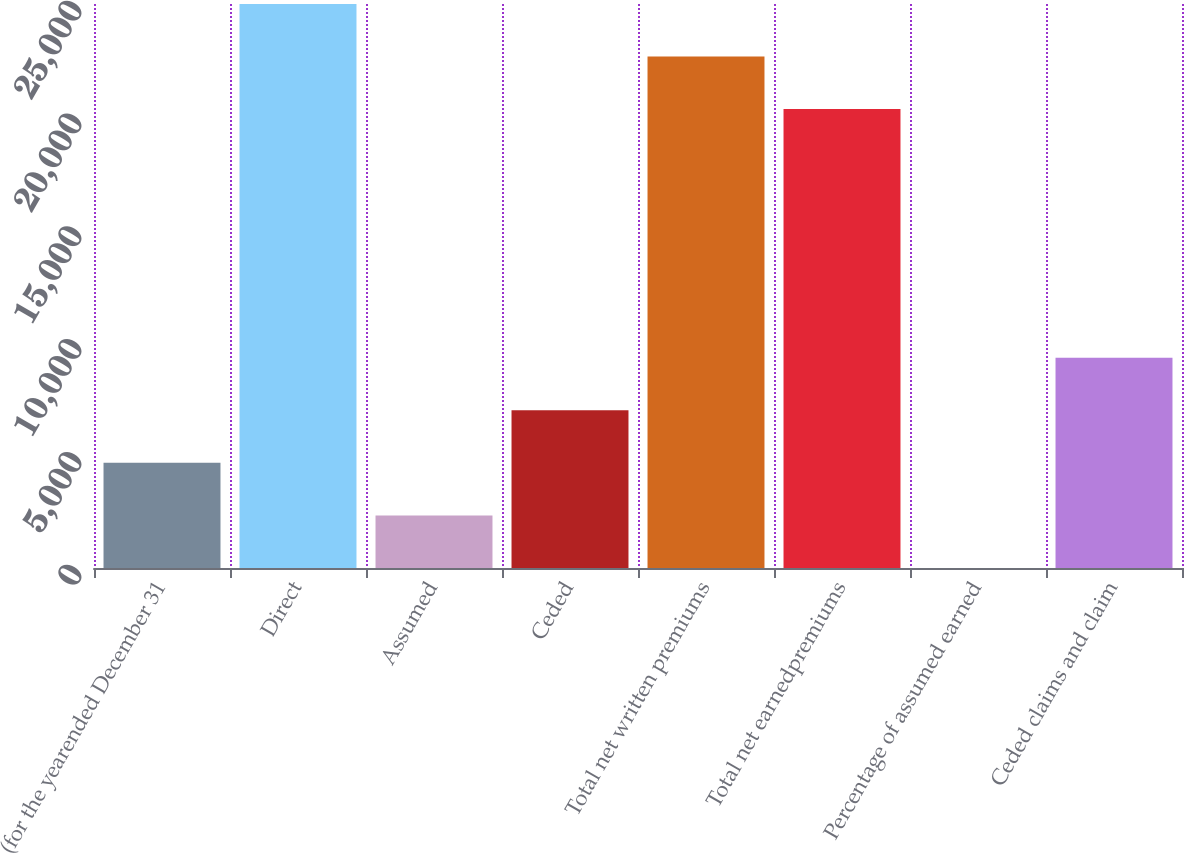Convert chart to OTSL. <chart><loc_0><loc_0><loc_500><loc_500><bar_chart><fcel>(for the yearended December 31<fcel>Direct<fcel>Assumed<fcel>Ceded<fcel>Total net written premiums<fcel>Total net earnedpremiums<fcel>Percentage of assumed earned<fcel>Ceded claims and claim<nl><fcel>4659.8<fcel>24998.3<fcel>2331.15<fcel>6988.45<fcel>22669.7<fcel>20341<fcel>2.5<fcel>9317.1<nl></chart> 